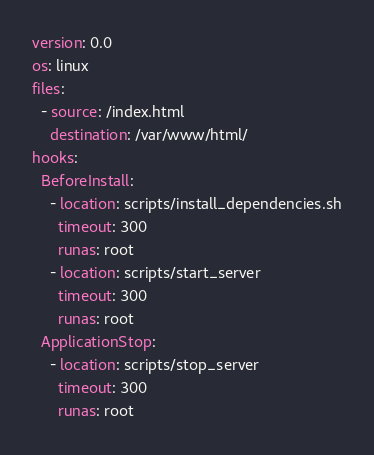<code> <loc_0><loc_0><loc_500><loc_500><_YAML_>version: 0.0
os: linux
files:
  - source: /index.html
    destination: /var/www/html/
hooks:
  BeforeInstall:
    - location: scripts/install_dependencies.sh
      timeout: 300
      runas: root
    - location: scripts/start_server
      timeout: 300
      runas: root
  ApplicationStop:
    - location: scripts/stop_server
      timeout: 300
      runas: root

</code> 